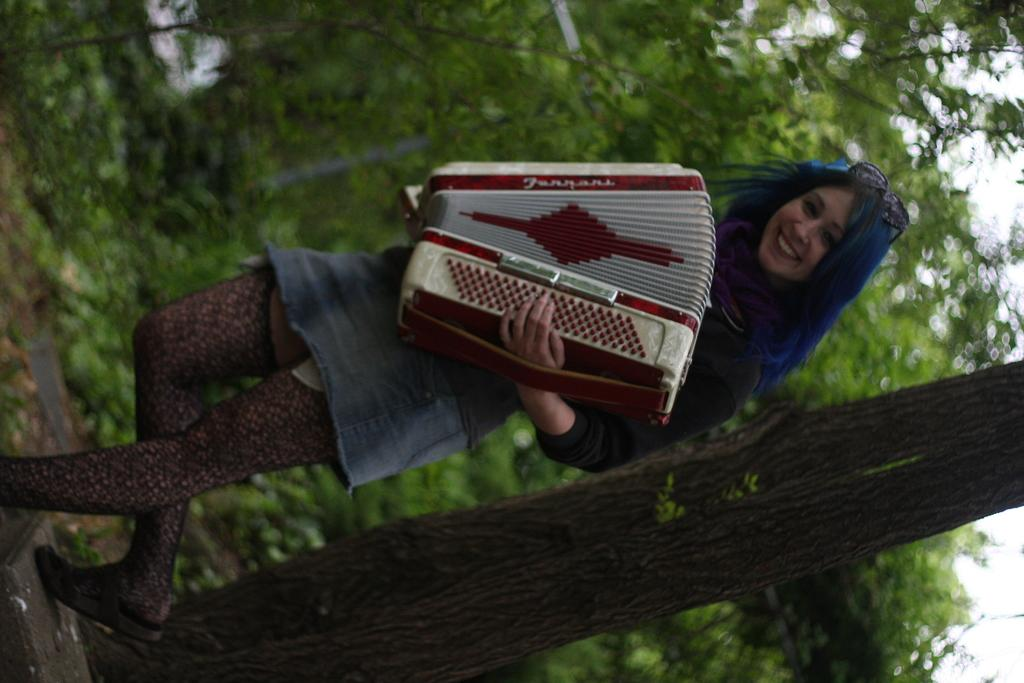What is the main subject of the image? The main subject of the image is a woman standing. What is the woman holding in the image? The woman is holding an object. What type of natural environment can be seen in the image? Trees are visible in the image, indicating a natural environment. What is visible at the top of the image? The sky is visible at the top of the image. What type of behavior can be observed in the woman's question about the use of the object? There is no question or behavior related to the use of the object in the image, as it only shows the woman holding an object without any context or interaction. 